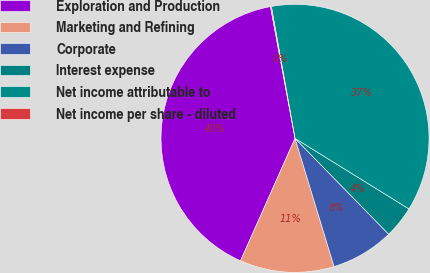Convert chart. <chart><loc_0><loc_0><loc_500><loc_500><pie_chart><fcel>Exploration and Production<fcel>Marketing and Refining<fcel>Corporate<fcel>Interest expense<fcel>Net income attributable to<fcel>Net income per share - diluted<nl><fcel>40.4%<fcel>11.37%<fcel>7.61%<fcel>3.86%<fcel>36.65%<fcel>0.11%<nl></chart> 